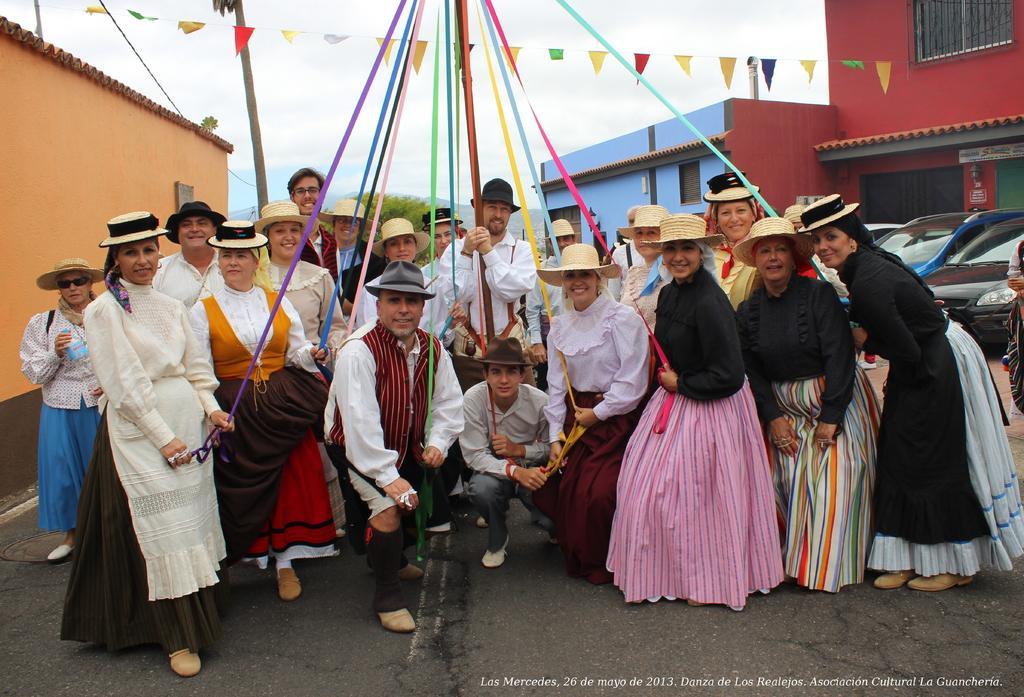Please provide a concise description of this image. In this image we can see men and women are standing, few are holding colorful ribbons in their hand. In the background, we can see trees, buildings, wooden pole and flags. The sky is covered with clouds. We can see cars on the right side of the image. 